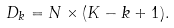<formula> <loc_0><loc_0><loc_500><loc_500>D _ { k } = N \times ( K - k + 1 ) .</formula> 